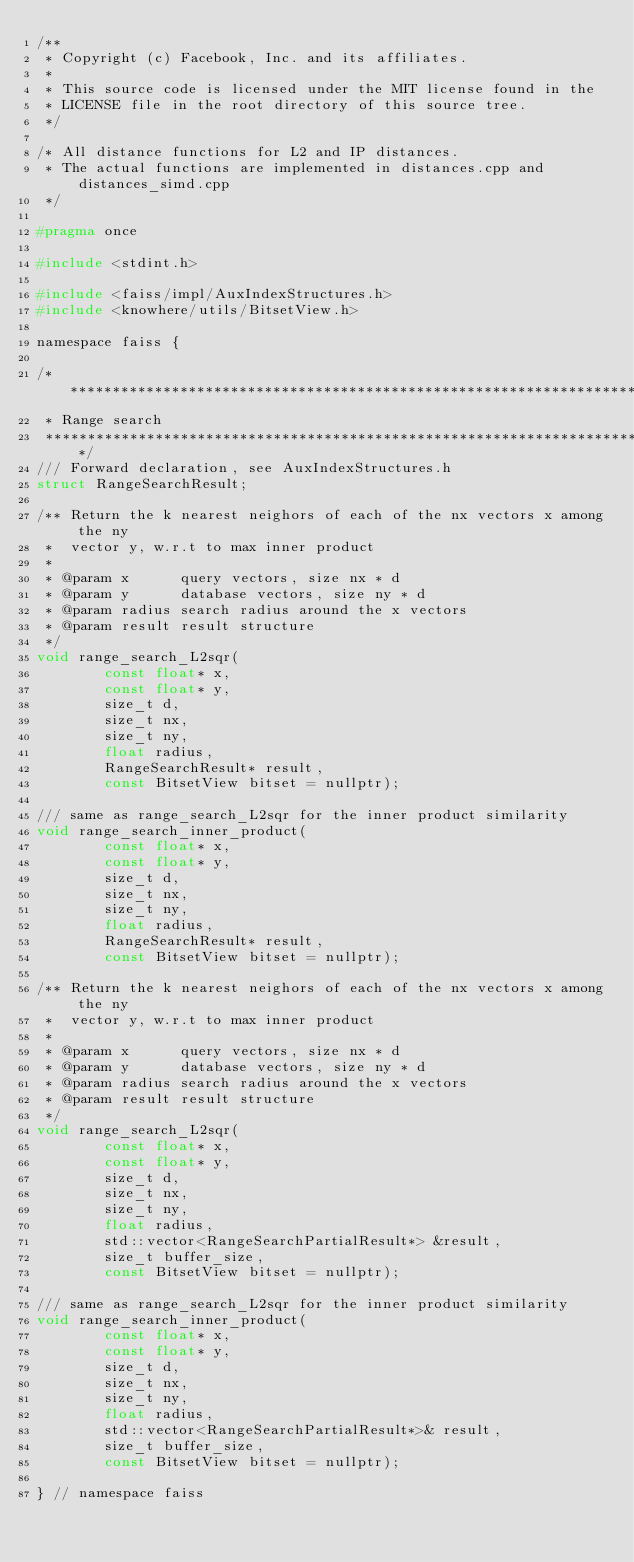<code> <loc_0><loc_0><loc_500><loc_500><_C_>/**
 * Copyright (c) Facebook, Inc. and its affiliates.
 *
 * This source code is licensed under the MIT license found in the
 * LICENSE file in the root directory of this source tree.
 */

/* All distance functions for L2 and IP distances.
 * The actual functions are implemented in distances.cpp and distances_simd.cpp
 */

#pragma once

#include <stdint.h>

#include <faiss/impl/AuxIndexStructures.h>
#include <knowhere/utils/BitsetView.h>

namespace faiss {

/***************************************************************************
 * Range search
 ***************************************************************************/
/// Forward declaration, see AuxIndexStructures.h
struct RangeSearchResult;

/** Return the k nearest neighors of each of the nx vectors x among the ny
 *  vector y, w.r.t to max inner product
 *
 * @param x      query vectors, size nx * d
 * @param y      database vectors, size ny * d
 * @param radius search radius around the x vectors
 * @param result result structure
 */
void range_search_L2sqr(
        const float* x,
        const float* y,
        size_t d,
        size_t nx,
        size_t ny,
        float radius,
        RangeSearchResult* result,
        const BitsetView bitset = nullptr);

/// same as range_search_L2sqr for the inner product similarity
void range_search_inner_product(
        const float* x,
        const float* y,
        size_t d,
        size_t nx,
        size_t ny,
        float radius,
        RangeSearchResult* result,
        const BitsetView bitset = nullptr);

/** Return the k nearest neighors of each of the nx vectors x among the ny
 *  vector y, w.r.t to max inner product
 *
 * @param x      query vectors, size nx * d
 * @param y      database vectors, size ny * d
 * @param radius search radius around the x vectors
 * @param result result structure
 */
void range_search_L2sqr(
        const float* x,
        const float* y,
        size_t d,
        size_t nx,
        size_t ny,
        float radius,
        std::vector<RangeSearchPartialResult*> &result,
        size_t buffer_size,
        const BitsetView bitset = nullptr);

/// same as range_search_L2sqr for the inner product similarity
void range_search_inner_product(
        const float* x,
        const float* y,
        size_t d,
        size_t nx,
        size_t ny,
        float radius,
        std::vector<RangeSearchPartialResult*>& result,
        size_t buffer_size,
        const BitsetView bitset = nullptr);

} // namespace faiss
</code> 